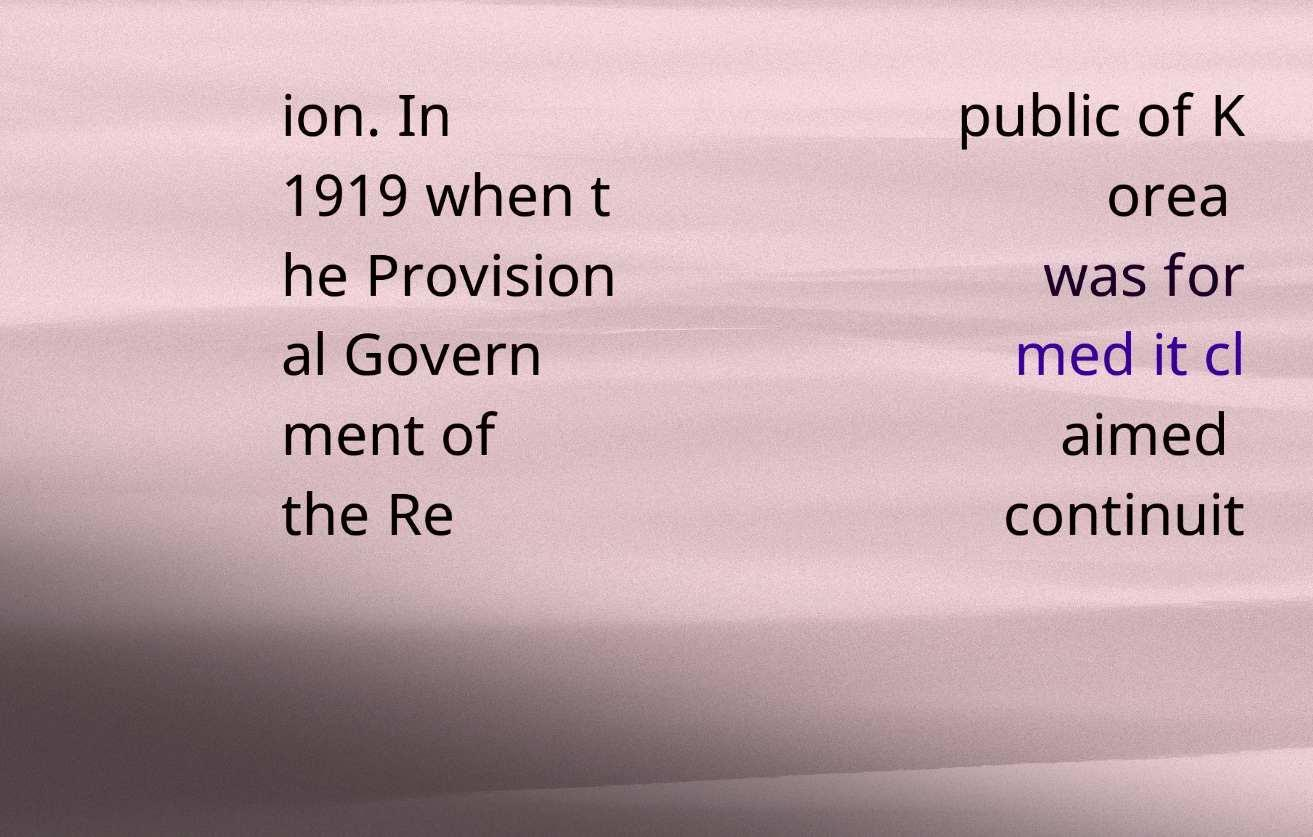For documentation purposes, I need the text within this image transcribed. Could you provide that? ion. In 1919 when t he Provision al Govern ment of the Re public of K orea was for med it cl aimed continuit 